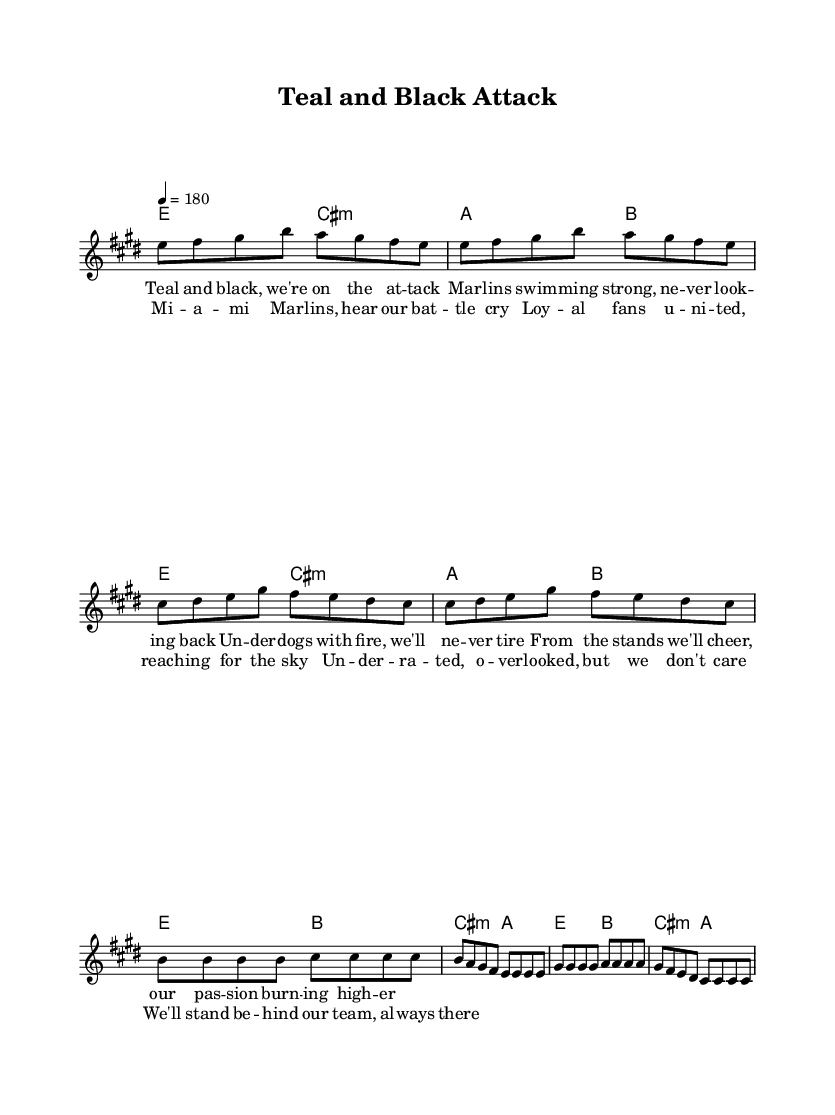What is the key signature of this music? The key signature is E major, which has four sharps (F#, C#, G#, D#). This can be determined by examining the key signature section in the sheet music, which is located after the clef sign at the beginning of the staff.
Answer: E major What is the time signature of this music? The time signature is 4/4, which is indicated at the beginning of the staff. This means there are four beats per measure and a quarter note receives one beat.
Answer: 4/4 What is the tempo marking for this piece? The tempo marking is 180, which means the piece should be played at a lively pace of 180 beats per minute. This is indicated in the tempo section at the beginning of the score.
Answer: 180 How many measures are in the verse section? The verse section contains eight measures. By counting each set of notes that aligns with the measures indicated in the sheet music, you can determine the total for the verse portion.
Answer: Eight What do the lyrics express about the fanbase? The lyrics express a sense of loyalty and passion from the fans, as they rally behind the Marlins and emphasize their determination to support the team regardless of the odds. This dedication to underdog status is a common theme in punk anthems.
Answer: Loyalty and passion What type of chord progression is used in the chorus? The chorus employs a simple chord progression using E major, B major, and C# minor, which creates a strong harmonic foundation typical for punk music anthems that resonate with anthemic qualities. The chord names above the staff indicate this progression.
Answer: E, B, C# minor How do the lyrics reflect the underdog theme? The lyrics highlight the Marlins as underdogs who are “overlooked” yet fiercely supported by their fans, conveying the spirit of fighting against the odds, which is a hallmark of punk anthems celebrating such teams. This theme is prevalent throughout the verse and chorus.
Answer: Underdogs 